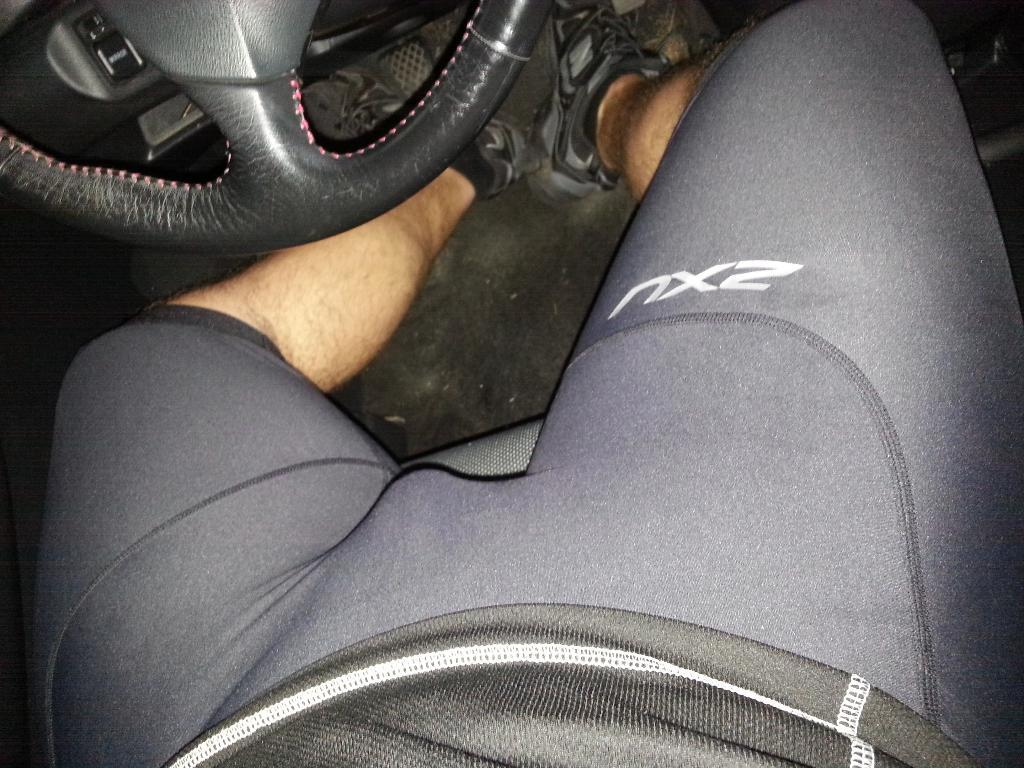What is the person in the image doing? The person is seated in the car. What can be seen in the top left hand corner of the image? The steering wheel is visible in the top left hand corner of the image. What type of silk underwear is the person wearing in the image? There is no information about the person's clothing in the image, and silk underwear is not mentioned in the provided facts. 